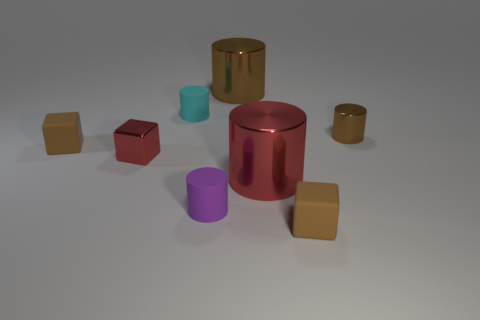What number of metal cylinders have the same color as the tiny metal cube?
Ensure brevity in your answer.  1. What is the color of the tiny matte object that is behind the big red cylinder and to the right of the tiny red block?
Offer a terse response. Cyan. What is the shape of the tiny metal thing behind the tiny red thing?
Your answer should be compact. Cylinder. There is a metal cylinder that is in front of the brown matte object to the left of the small matte object that is in front of the purple cylinder; how big is it?
Offer a terse response. Large. There is a tiny cylinder that is to the right of the large red thing; how many cyan matte cylinders are in front of it?
Provide a succinct answer. 0. There is a thing that is both to the right of the big red cylinder and in front of the large red shiny thing; what size is it?
Ensure brevity in your answer.  Small. How many metal objects are spheres or tiny cyan cylinders?
Your answer should be compact. 0. What is the red cube made of?
Make the answer very short. Metal. The big object that is to the right of the large shiny cylinder behind the big red metal cylinder that is right of the tiny cyan cylinder is made of what material?
Offer a very short reply. Metal. There is a metal thing that is the same size as the red cube; what shape is it?
Provide a succinct answer. Cylinder. 